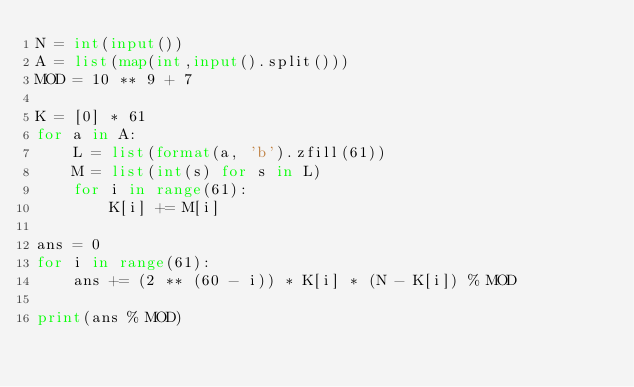Convert code to text. <code><loc_0><loc_0><loc_500><loc_500><_Python_>N = int(input())
A = list(map(int,input().split()))
MOD = 10 ** 9 + 7

K = [0] * 61
for a in A:
    L = list(format(a, 'b').zfill(61))
    M = list(int(s) for s in L)
    for i in range(61):
        K[i] += M[i]

ans = 0
for i in range(61):
    ans += (2 ** (60 - i)) * K[i] * (N - K[i]) % MOD

print(ans % MOD)</code> 